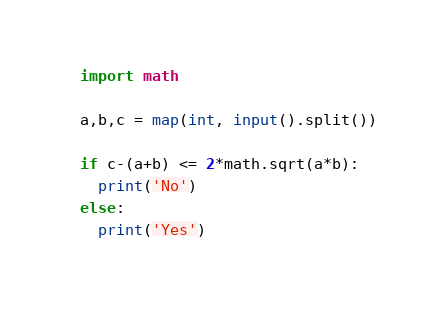<code> <loc_0><loc_0><loc_500><loc_500><_Python_>import math

a,b,c = map(int, input().split())

if c-(a+b) <= 2*math.sqrt(a*b):
  print('No')
else:
  print('Yes')
</code> 